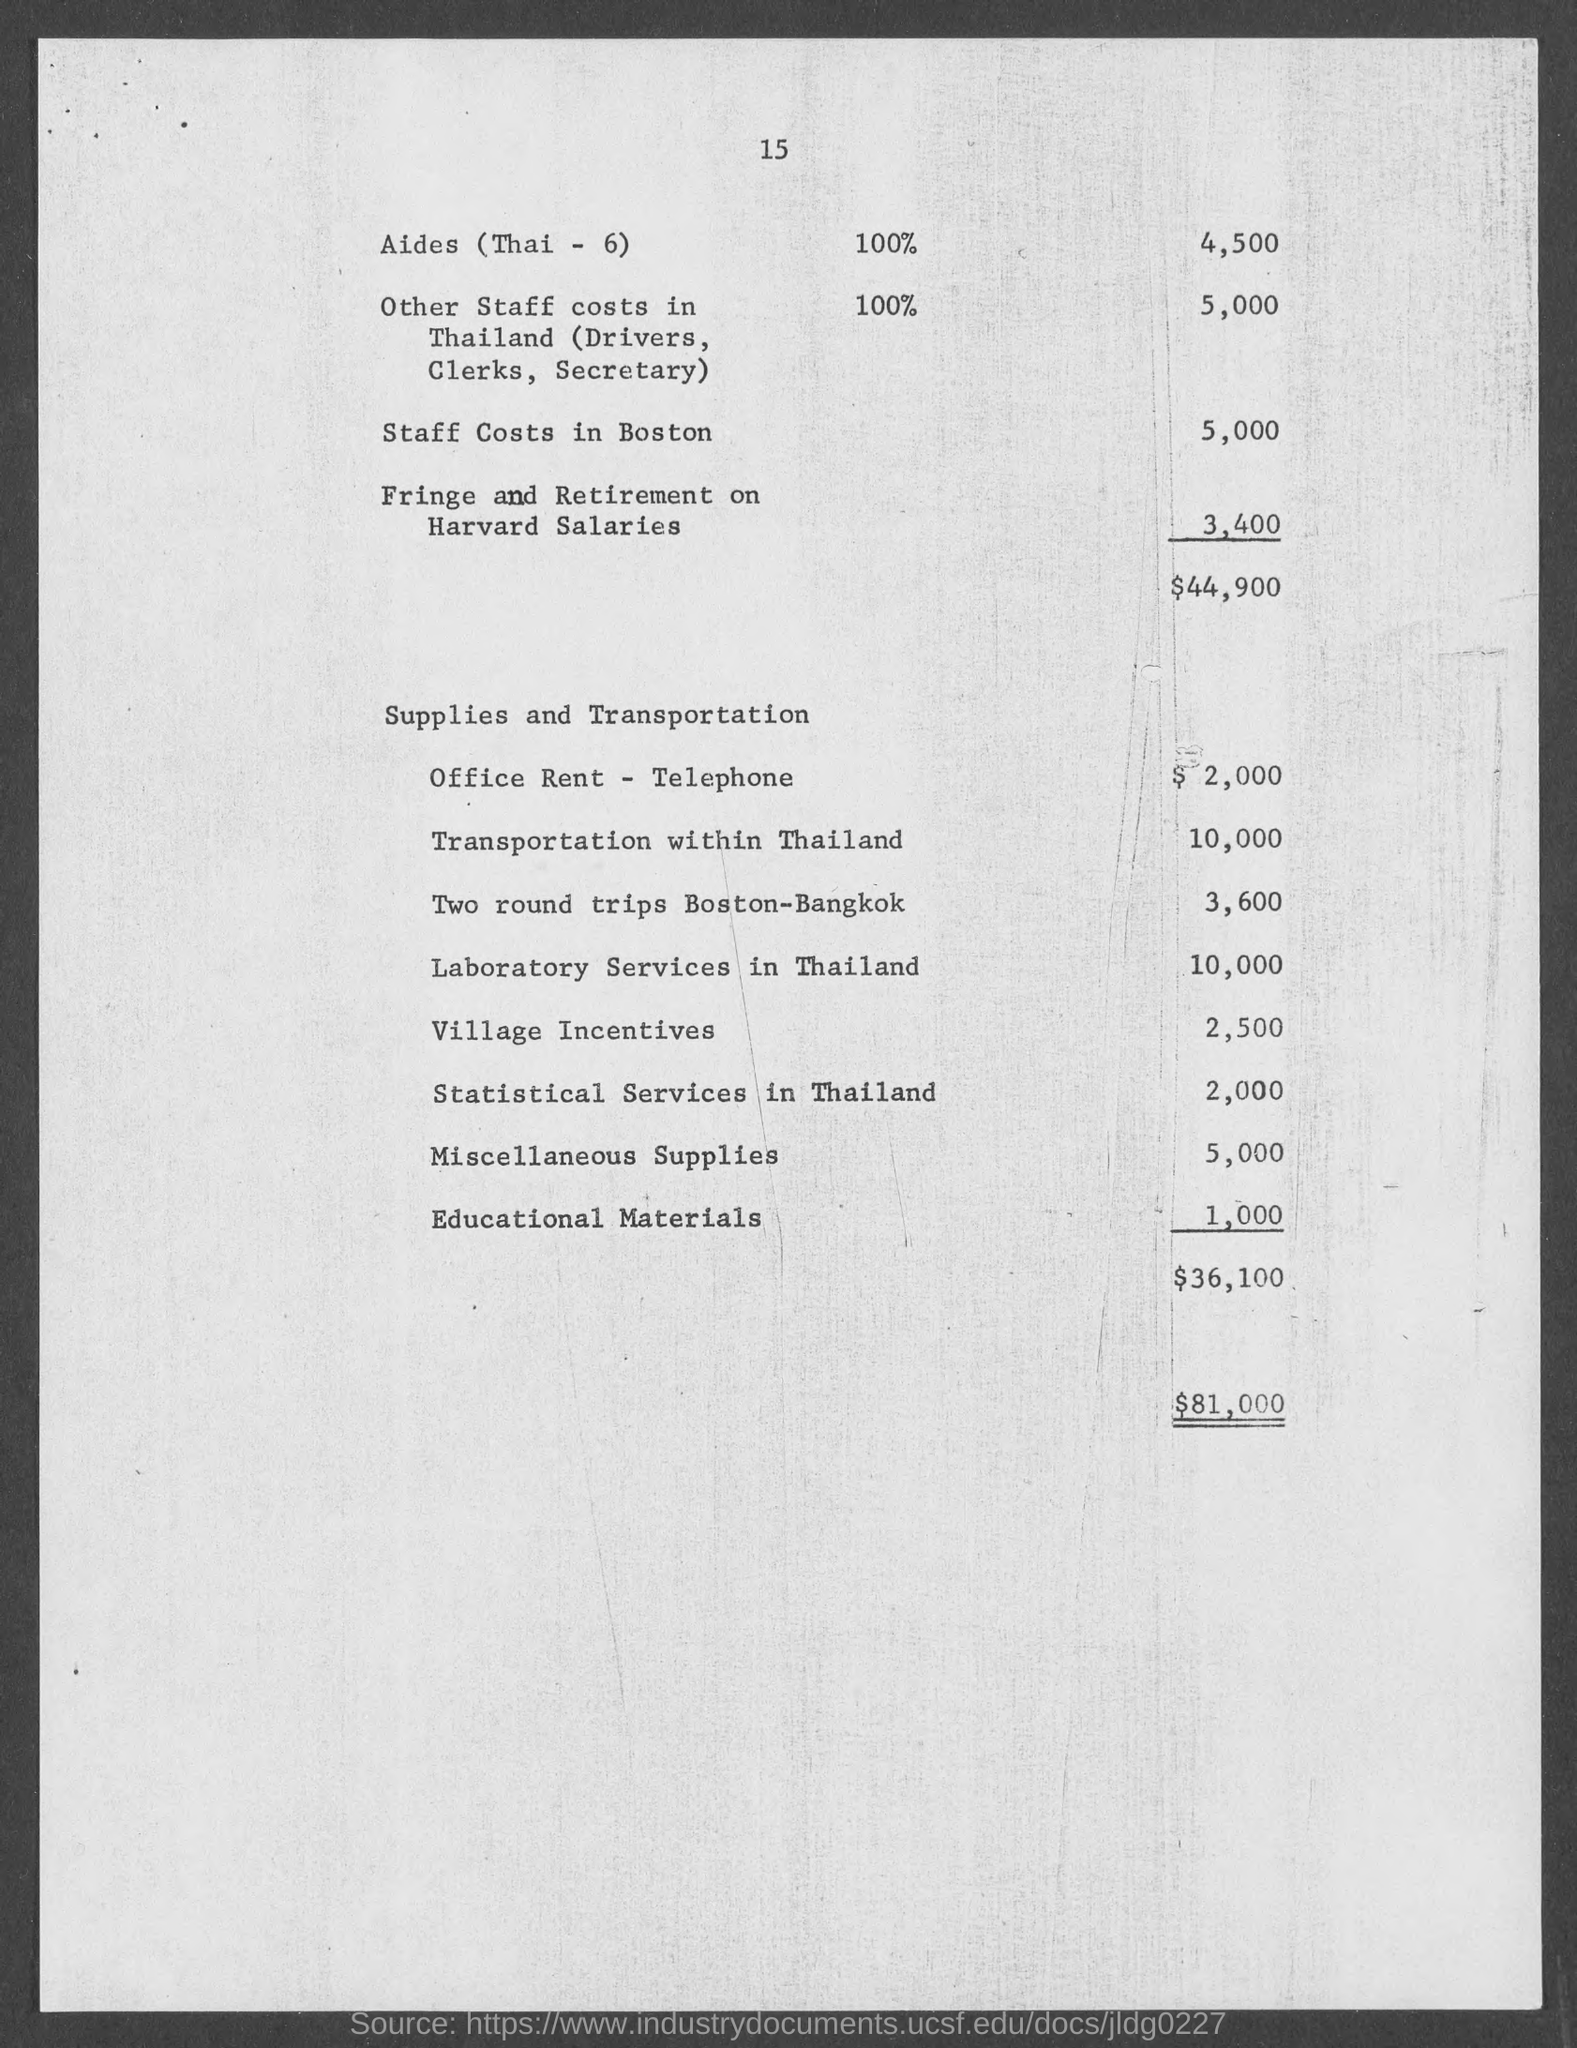What is the Other staff costs in Thailand?
Keep it short and to the point. 5,000. What is the staff costs in Boston?
Your answer should be very brief. 5,000. What is the Fringe and Retirement on Harvard Salaries?
Your response must be concise. 3,400. What is the Cost for Office Rent - Telephone?
Offer a terse response. $2,000. What is the Cost for Transportation within Thailand?
Your answer should be very brief. 10,000. What is the Cost for Two round trips Boston-Bangkok?
Provide a short and direct response. 3,600. What is the Cost for Laboratory services in Thailand?
Your answer should be compact. 10,000. What is the Cost for Village Incentives?
Ensure brevity in your answer.  2,500. What is the Cost for Statistical services in Thailand?
Make the answer very short. 2,000. What is the Cost for Miscellaneous Supplies?
Provide a short and direct response. 5,000. 